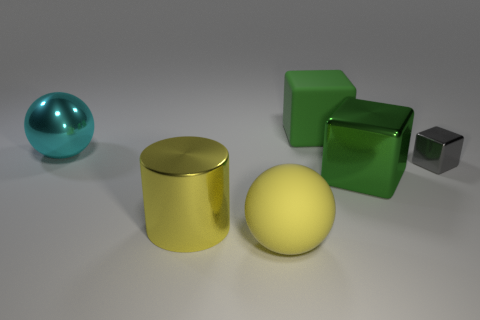Subtract all gray blocks. How many blocks are left? 2 Add 3 tiny cyan metal cylinders. How many objects exist? 9 Subtract all gray blocks. How many blocks are left? 2 Subtract 1 blocks. How many blocks are left? 2 Subtract all balls. How many objects are left? 4 Subtract all purple cubes. Subtract all green balls. How many cubes are left? 3 Subtract all green cylinders. How many gray cubes are left? 1 Subtract all big yellow rubber spheres. Subtract all tiny yellow metal balls. How many objects are left? 5 Add 1 metallic blocks. How many metallic blocks are left? 3 Add 4 brown objects. How many brown objects exist? 4 